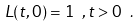Convert formula to latex. <formula><loc_0><loc_0><loc_500><loc_500>L ( t , 0 ) = 1 \ , t > 0 \ .</formula> 